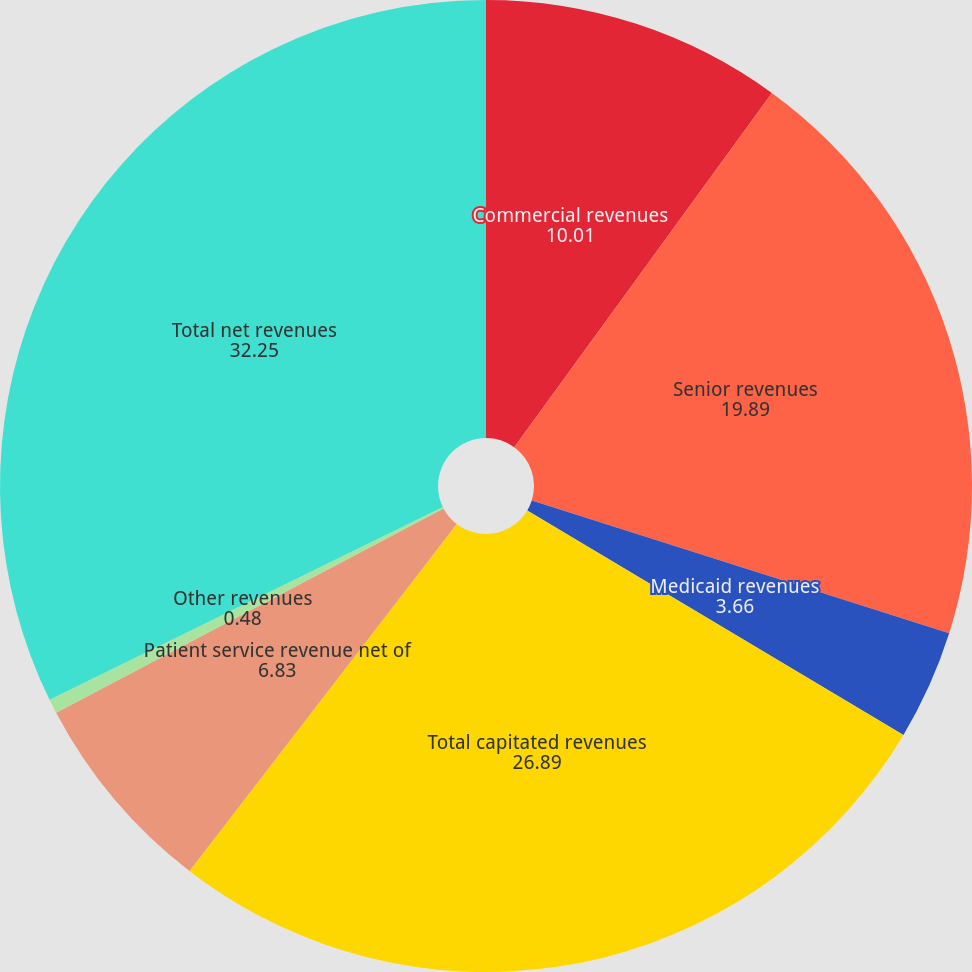Convert chart to OTSL. <chart><loc_0><loc_0><loc_500><loc_500><pie_chart><fcel>Commercial revenues<fcel>Senior revenues<fcel>Medicaid revenues<fcel>Total capitated revenues<fcel>Patient service revenue net of<fcel>Other revenues<fcel>Total net revenues<nl><fcel>10.01%<fcel>19.89%<fcel>3.66%<fcel>26.89%<fcel>6.83%<fcel>0.48%<fcel>32.25%<nl></chart> 